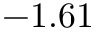Convert formula to latex. <formula><loc_0><loc_0><loc_500><loc_500>- 1 . 6 1</formula> 